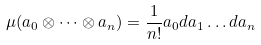<formula> <loc_0><loc_0><loc_500><loc_500>\mu ( a _ { 0 } \otimes \dots \otimes a _ { n } ) = \frac { 1 } { n ! } a _ { 0 } d a _ { 1 } \dots d a _ { n }</formula> 